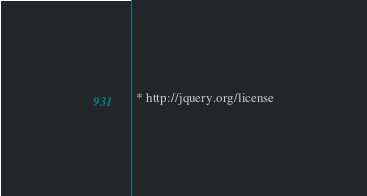<code> <loc_0><loc_0><loc_500><loc_500><_CSS_> * http://jquery.org/license</code> 